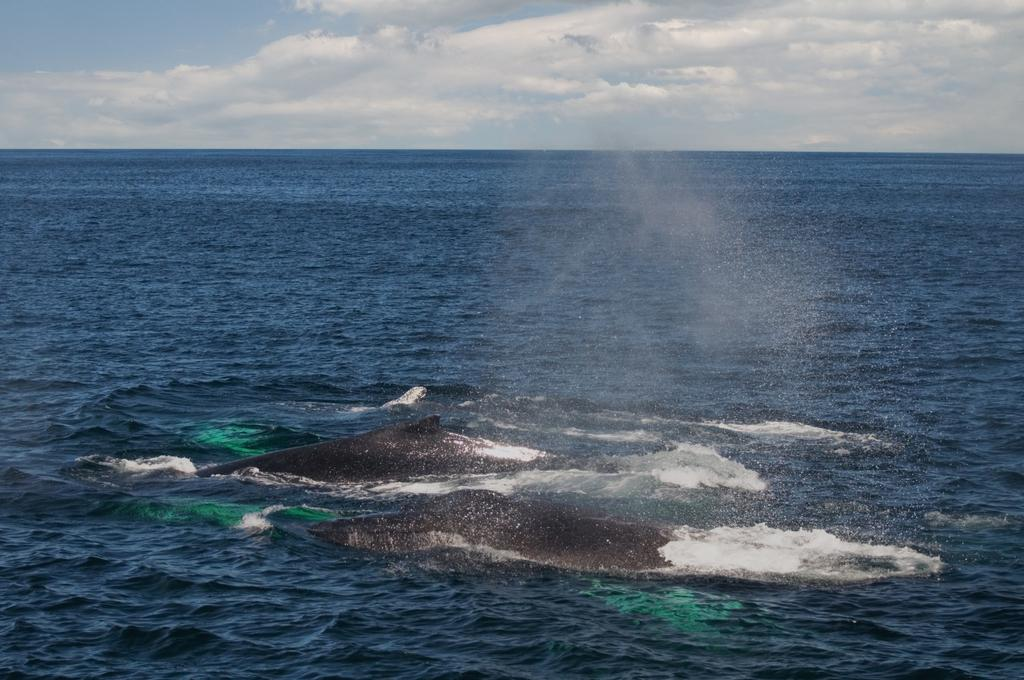What is visible in the image? Water is visible in the image. What type of creatures can be seen in the water? There are aquatic animals in the water. What type of payment method is accepted at this place? There is no reference to a place or payment method in the image, as it only features water and aquatic animals. 